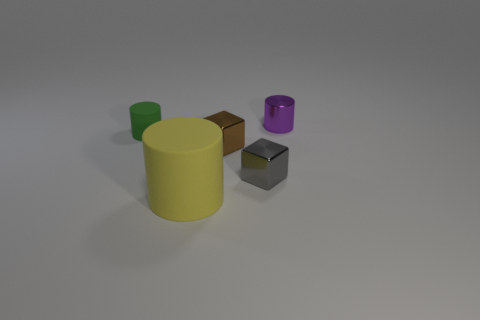Subtract all metallic cylinders. How many cylinders are left? 2 Add 2 small brown cubes. How many objects exist? 7 Subtract all purple cylinders. How many cylinders are left? 2 Subtract 2 blocks. How many blocks are left? 0 Add 5 yellow rubber things. How many yellow rubber things exist? 6 Subtract 0 brown cylinders. How many objects are left? 5 Subtract all blocks. How many objects are left? 3 Subtract all purple cylinders. Subtract all green balls. How many cylinders are left? 2 Subtract all brown balls. How many yellow blocks are left? 0 Subtract all large gray rubber spheres. Subtract all yellow rubber objects. How many objects are left? 4 